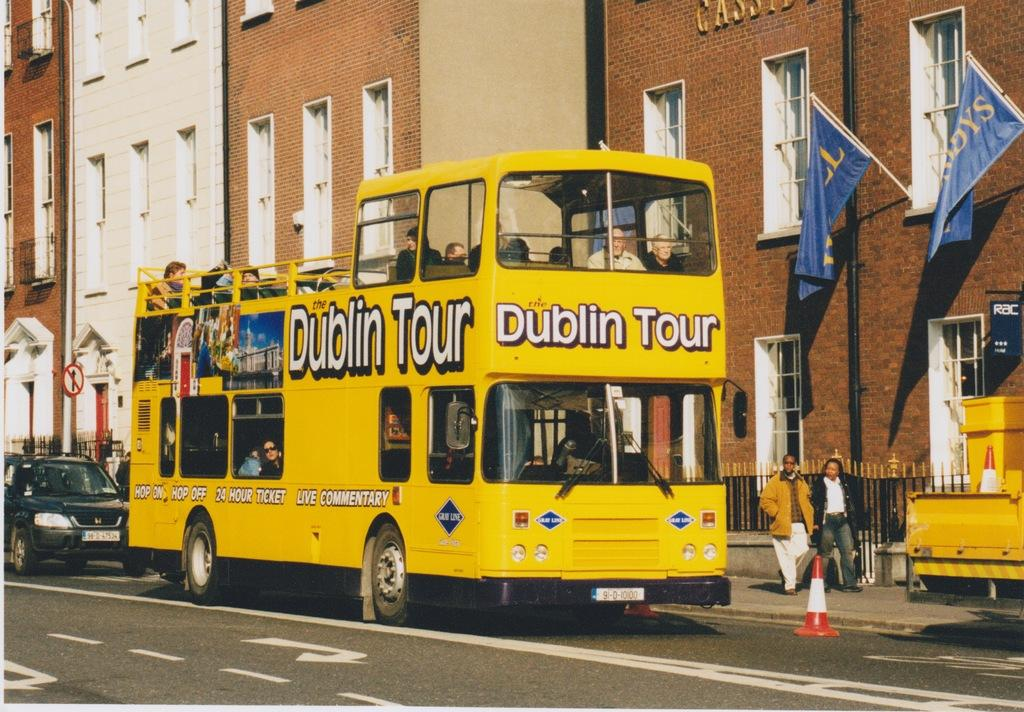<image>
Create a compact narrative representing the image presented. A double decker Dublin Tour bus is driving is passing by rows of tall buildings. 